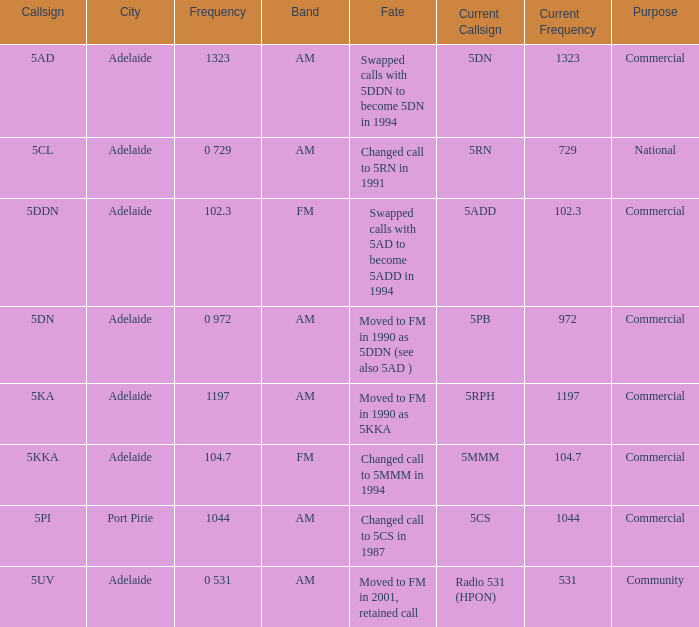Which area served has a Callsign of 5ddn? Adelaide. 